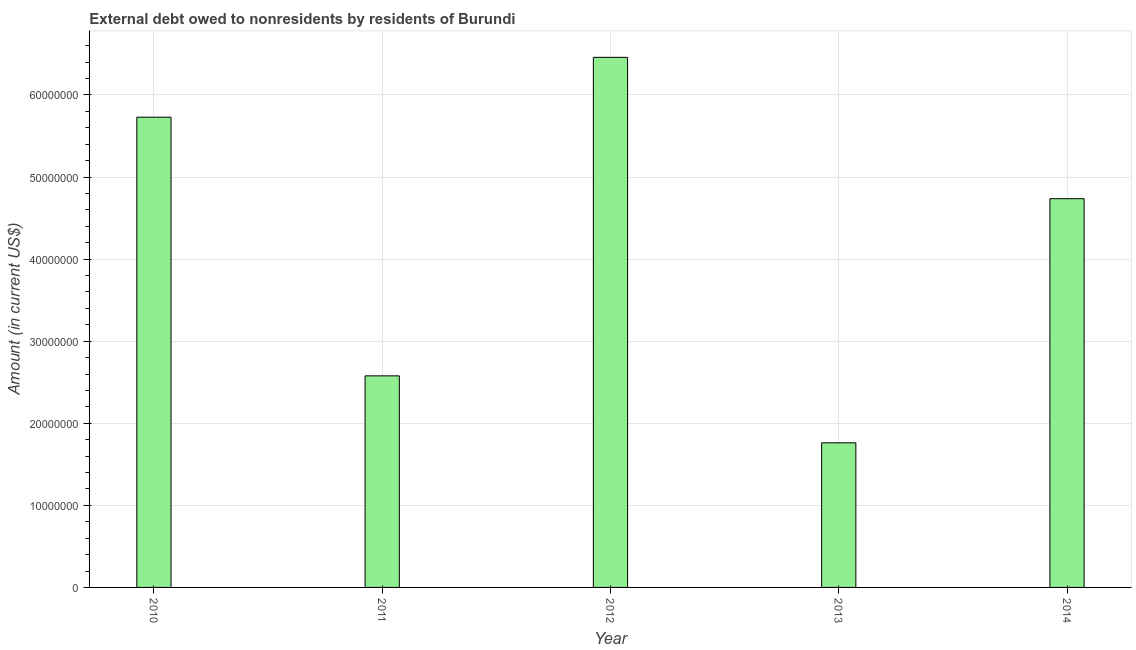Does the graph contain grids?
Offer a terse response. Yes. What is the title of the graph?
Keep it short and to the point. External debt owed to nonresidents by residents of Burundi. What is the debt in 2012?
Keep it short and to the point. 6.46e+07. Across all years, what is the maximum debt?
Provide a short and direct response. 6.46e+07. Across all years, what is the minimum debt?
Ensure brevity in your answer.  1.76e+07. What is the sum of the debt?
Ensure brevity in your answer.  2.13e+08. What is the difference between the debt in 2011 and 2014?
Provide a short and direct response. -2.16e+07. What is the average debt per year?
Offer a very short reply. 4.25e+07. What is the median debt?
Your response must be concise. 4.74e+07. What is the ratio of the debt in 2011 to that in 2012?
Ensure brevity in your answer.  0.4. Is the debt in 2010 less than that in 2013?
Make the answer very short. No. Is the difference between the debt in 2010 and 2012 greater than the difference between any two years?
Offer a terse response. No. What is the difference between the highest and the second highest debt?
Offer a very short reply. 7.30e+06. What is the difference between the highest and the lowest debt?
Provide a succinct answer. 4.70e+07. How many bars are there?
Offer a very short reply. 5. How many years are there in the graph?
Make the answer very short. 5. What is the difference between two consecutive major ticks on the Y-axis?
Keep it short and to the point. 1.00e+07. What is the Amount (in current US$) in 2010?
Your answer should be compact. 5.73e+07. What is the Amount (in current US$) in 2011?
Ensure brevity in your answer.  2.58e+07. What is the Amount (in current US$) of 2012?
Ensure brevity in your answer.  6.46e+07. What is the Amount (in current US$) in 2013?
Provide a succinct answer. 1.76e+07. What is the Amount (in current US$) in 2014?
Give a very brief answer. 4.74e+07. What is the difference between the Amount (in current US$) in 2010 and 2011?
Offer a terse response. 3.15e+07. What is the difference between the Amount (in current US$) in 2010 and 2012?
Your response must be concise. -7.30e+06. What is the difference between the Amount (in current US$) in 2010 and 2013?
Make the answer very short. 3.97e+07. What is the difference between the Amount (in current US$) in 2010 and 2014?
Provide a short and direct response. 9.93e+06. What is the difference between the Amount (in current US$) in 2011 and 2012?
Your answer should be very brief. -3.88e+07. What is the difference between the Amount (in current US$) in 2011 and 2013?
Offer a terse response. 8.16e+06. What is the difference between the Amount (in current US$) in 2011 and 2014?
Keep it short and to the point. -2.16e+07. What is the difference between the Amount (in current US$) in 2012 and 2013?
Provide a succinct answer. 4.70e+07. What is the difference between the Amount (in current US$) in 2012 and 2014?
Your response must be concise. 1.72e+07. What is the difference between the Amount (in current US$) in 2013 and 2014?
Your response must be concise. -2.97e+07. What is the ratio of the Amount (in current US$) in 2010 to that in 2011?
Keep it short and to the point. 2.22. What is the ratio of the Amount (in current US$) in 2010 to that in 2012?
Give a very brief answer. 0.89. What is the ratio of the Amount (in current US$) in 2010 to that in 2013?
Your response must be concise. 3.25. What is the ratio of the Amount (in current US$) in 2010 to that in 2014?
Your answer should be very brief. 1.21. What is the ratio of the Amount (in current US$) in 2011 to that in 2012?
Give a very brief answer. 0.4. What is the ratio of the Amount (in current US$) in 2011 to that in 2013?
Ensure brevity in your answer.  1.46. What is the ratio of the Amount (in current US$) in 2011 to that in 2014?
Ensure brevity in your answer.  0.54. What is the ratio of the Amount (in current US$) in 2012 to that in 2013?
Offer a terse response. 3.67. What is the ratio of the Amount (in current US$) in 2012 to that in 2014?
Your answer should be compact. 1.36. What is the ratio of the Amount (in current US$) in 2013 to that in 2014?
Offer a terse response. 0.37. 